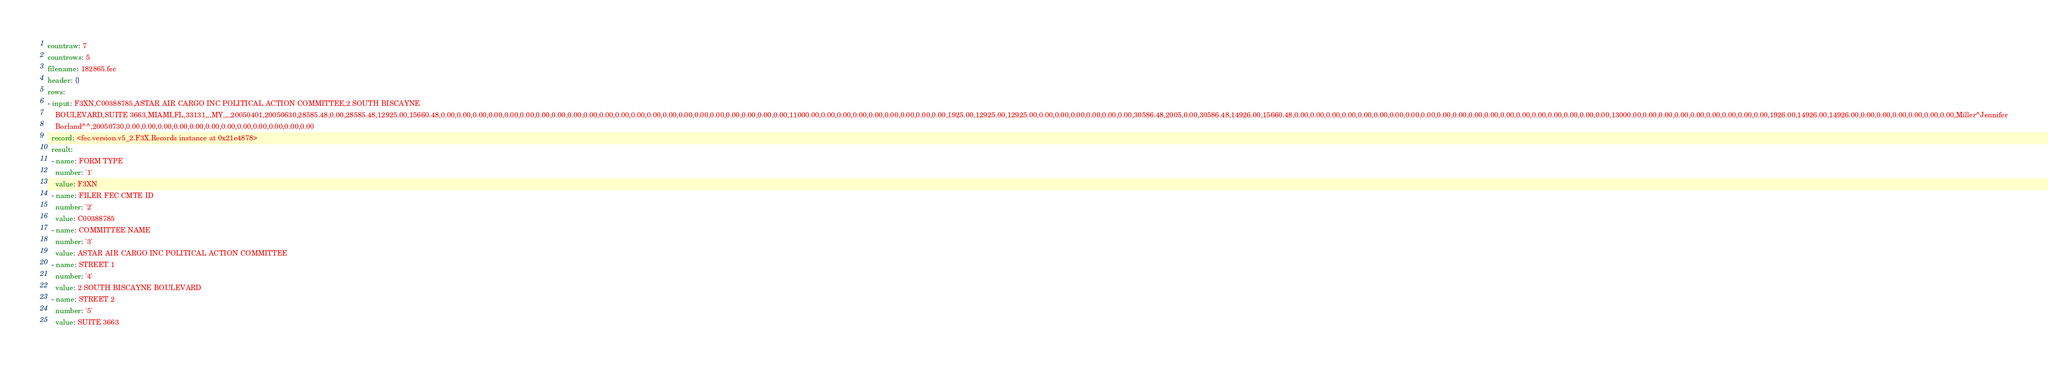<code> <loc_0><loc_0><loc_500><loc_500><_YAML_>countraw: 7
countrows: 5
filename: 182865.fec
header: {}
rows:
- input: F3XN,C00388785,ASTAR AIR CARGO INC POLITICAL ACTION COMMITTEE,2 SOUTH BISCAYNE
    BOULEVARD,SUITE 3663,MIAMI,FL,33131,,,MY,,,,20050401,20050630,28585.48,0.00,28585.48,12925.00,15660.48,0.00,0.00,0.00,0.00,0.00,0.00,0.00,0.00,0.00,0.00,0.00,0.00,0.00,0.00,0.00,0.00,0.00,0.00,0.00,0.00,0.00,0.00,11000.00,0.00,0.00,0.00,0.00,0.00,0.00,0.00,0.00,1925.00,12925.00,12925.00,0.00,0.00,0.00,0.00,0.00,0.00,30586.48,2005,0.00,30586.48,14926.00,15660.48,0.00,0.00,0.00,0.00,0.00,0.00,0.00,0.00,0.00,0.00,0.00,0.00,0.00,0.00,0.00,0.00,0.00,0.00,0.00,0.00,13000.00,0.00,0.00,0.00,0.00,0.00,0.00,0.00,0.00,1926.00,14926.00,14926.00,0.00,0.00,0.00,0.00,0.00,0.00,Miller^Jennifer
    Borland^^,20050730,0.00,0.00,0.00,0.00,0.00,0.00,0.00,0.00,0.00,0.00,0.00,0.00
  record: <fec.version.v5_2.F3X.Records instance at 0x21e4878>
  result:
  - name: FORM TYPE
    number: '1'
    value: F3XN
  - name: FILER FEC CMTE ID
    number: '2'
    value: C00388785
  - name: COMMITTEE NAME
    number: '3'
    value: ASTAR AIR CARGO INC POLITICAL ACTION COMMITTEE
  - name: STREET 1
    number: '4'
    value: 2 SOUTH BISCAYNE BOULEVARD
  - name: STREET 2
    number: '5'
    value: SUITE 3663</code> 